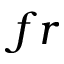<formula> <loc_0><loc_0><loc_500><loc_500>f r</formula> 